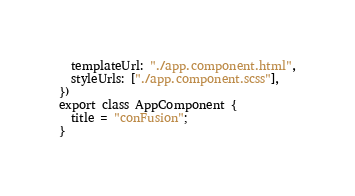Convert code to text. <code><loc_0><loc_0><loc_500><loc_500><_TypeScript_>  templateUrl: "./app.component.html",
  styleUrls: ["./app.component.scss"],
})
export class AppComponent {
  title = "conFusion";
}
</code> 